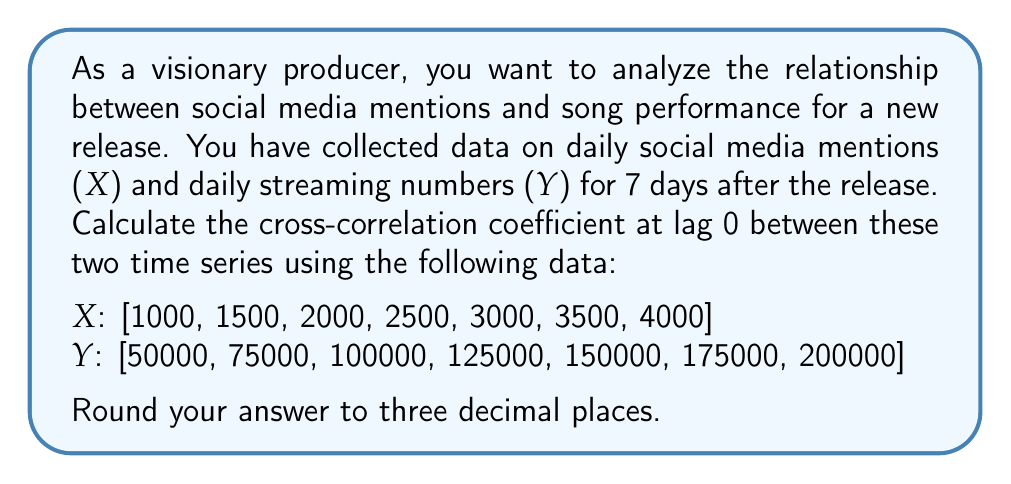Can you answer this question? To calculate the cross-correlation coefficient at lag 0, we'll use the formula:

$$ r_{xy}(0) = \frac{\sum_{t=1}^{N} (x_t - \bar{x})(y_t - \bar{y})}{\sqrt{\sum_{t=1}^{N} (x_t - \bar{x})^2 \sum_{t=1}^{N} (y_t - \bar{y})^2}} $$

Where:
$r_{xy}(0)$ is the cross-correlation coefficient at lag 0
$x_t$ and $y_t$ are the values of X and Y at time t
$\bar{x}$ and $\bar{y}$ are the means of X and Y
N is the number of observations

Step 1: Calculate the means
$\bar{x} = \frac{1000 + 1500 + 2000 + 2500 + 3000 + 3500 + 4000}{7} = 2500$
$\bar{y} = \frac{50000 + 75000 + 100000 + 125000 + 150000 + 175000 + 200000}{7} = 125000$

Step 2: Calculate $(x_t - \bar{x})$ and $(y_t - \bar{y})$ for each t
$(x_t - \bar{x})$: [-1500, -1000, -500, 0, 500, 1000, 1500]
$(y_t - \bar{y})$: [-75000, -50000, -25000, 0, 25000, 50000, 75000]

Step 3: Calculate $(x_t - \bar{x})(y_t - \bar{y})$ for each t and sum
$\sum_{t=1}^{N} (x_t - \bar{x})(y_t - \bar{y}) = 112500000 + 50000000 + 12500000 + 0 + 12500000 + 50000000 + 112500000 = 350000000$

Step 4: Calculate $(x_t - \bar{x})^2$ and $(y_t - \bar{y})^2$ for each t and sum
$\sum_{t=1}^{N} (x_t - \bar{x})^2 = 2250000 + 1000000 + 250000 + 0 + 250000 + 1000000 + 2250000 = 7000000$
$\sum_{t=1}^{N} (y_t - \bar{y})^2 = 5625000000 + 2500000000 + 625000000 + 0 + 625000000 + 2500000000 + 5625000000 = 17500000000$

Step 5: Apply the formula
$$ r_{xy}(0) = \frac{350000000}{\sqrt{7000000 \times 17500000000}} = \frac{350000000}{350000000} = 1 $$

The cross-correlation coefficient at lag 0 is exactly 1, indicating a perfect positive linear relationship between social media mentions and song performance.
Answer: 1.000 